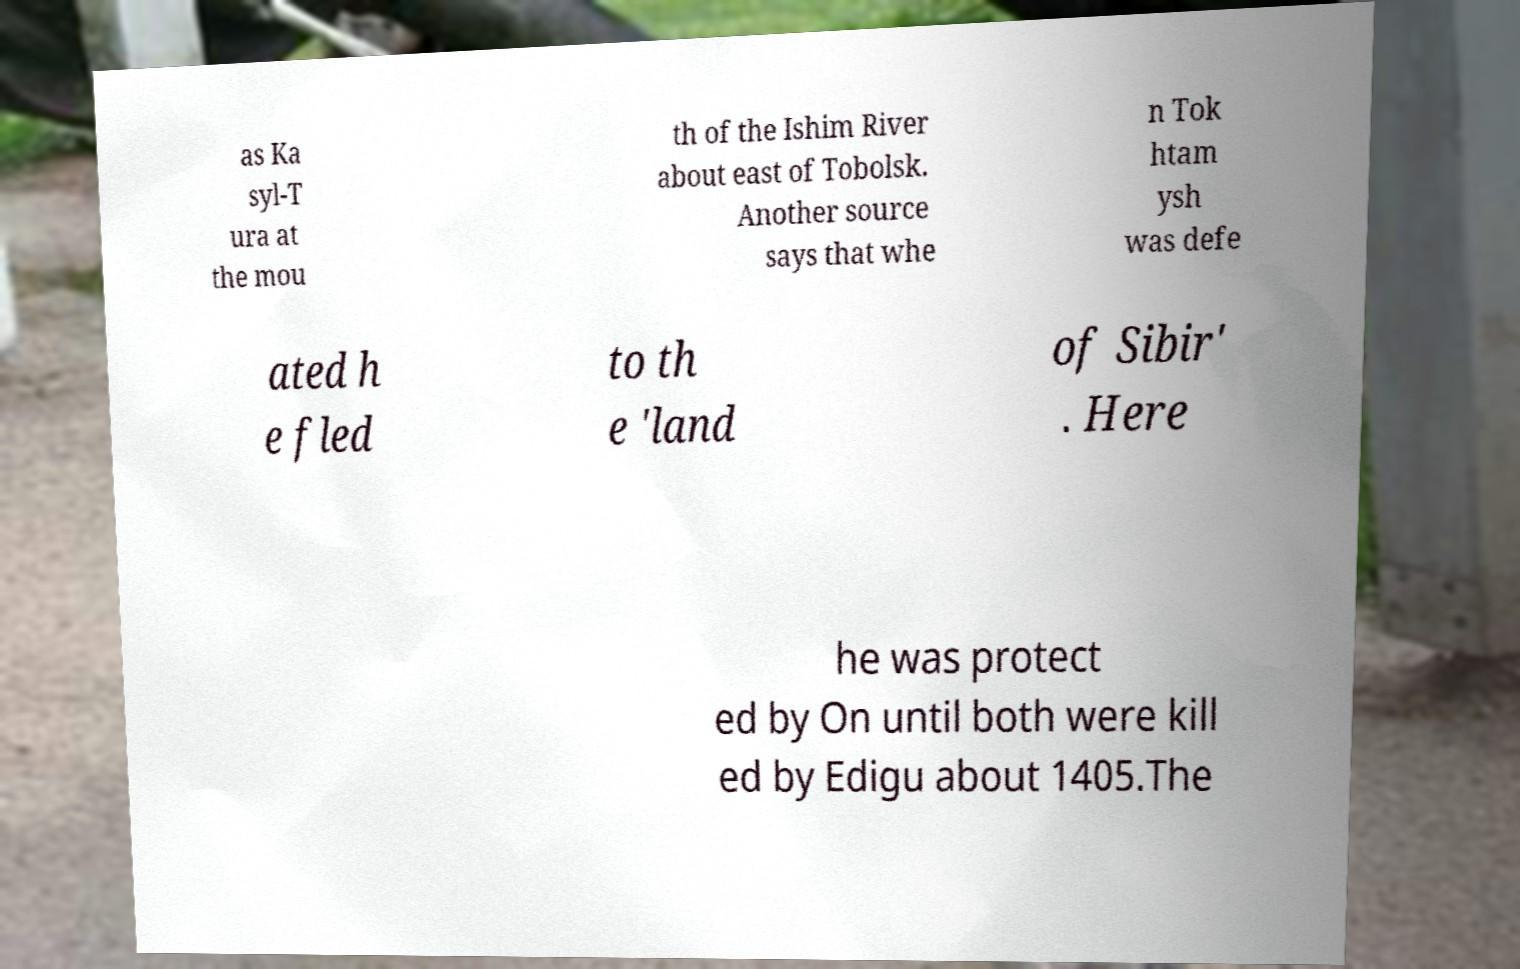Can you accurately transcribe the text from the provided image for me? as Ka syl-T ura at the mou th of the Ishim River about east of Tobolsk. Another source says that whe n Tok htam ysh was defe ated h e fled to th e 'land of Sibir' . Here he was protect ed by On until both were kill ed by Edigu about 1405.The 